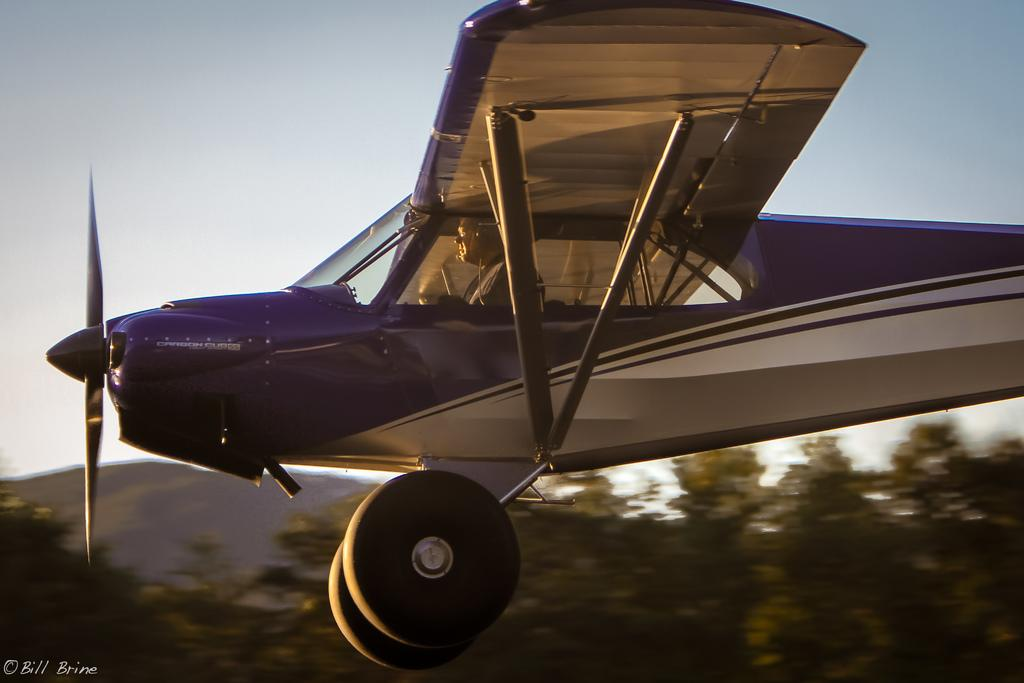What is the person in the image doing? There is a person sitting in an aeroplane in the image. What can be seen in the background of the image? There are a lot of trees visible in the image. What type of tax is being discussed in the image? There is no discussion of tax in the image; it features a person sitting in an aeroplane and trees in the background. Where is the lunchroom located in the image? There is no lunchroom present in the image. 